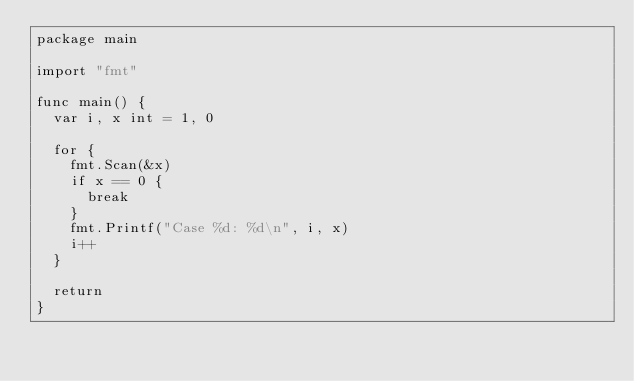Convert code to text. <code><loc_0><loc_0><loc_500><loc_500><_Go_>package main

import "fmt"

func main() {
	var i, x int = 1, 0

	for {
		fmt.Scan(&x)
		if x == 0 {
			break
		}
		fmt.Printf("Case %d: %d\n", i, x)
		i++
	}

	return
}

</code> 